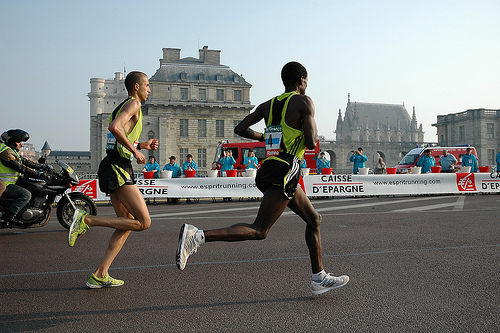Can you tell me what event is taking place in the image? The image captures a moment from a marathon or road race, with runners focused and maintaining a steady pace, as indicated by their athletic attire and numbered bibs. The presence of a motorbike and barriers suggests it's an organized event with safety measures in place. What does the presence of the audience suggest about the event? The onlookers visible behind the barriers, along with the event's branding and sponsors on the banners, hint at a significant event that draws public interest. The audience's presence reflects the communal and supportive spirit commonly associated with such athletic competitions. 